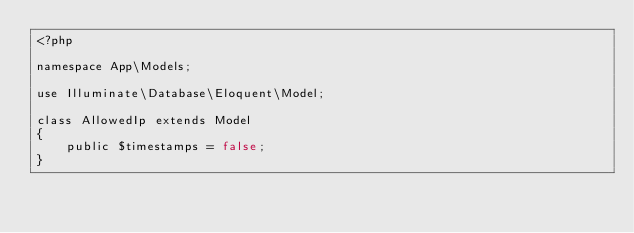<code> <loc_0><loc_0><loc_500><loc_500><_PHP_><?php

namespace App\Models;

use Illuminate\Database\Eloquent\Model;

class AllowedIp extends Model
{
    public $timestamps = false;
}
</code> 